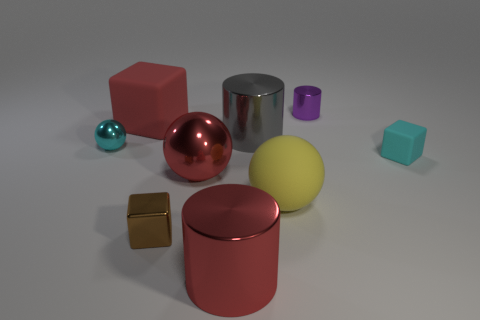Subtract all metallic balls. How many balls are left? 1 Subtract 1 blocks. How many blocks are left? 2 Subtract all red balls. How many balls are left? 2 Subtract all gray blocks. How many purple cylinders are left? 1 Add 4 large red metal things. How many large red metal things are left? 6 Add 8 metal balls. How many metal balls exist? 10 Subtract 1 red cubes. How many objects are left? 8 Subtract all cylinders. How many objects are left? 6 Subtract all blue cylinders. Subtract all yellow cubes. How many cylinders are left? 3 Subtract all large gray things. Subtract all big red cylinders. How many objects are left? 7 